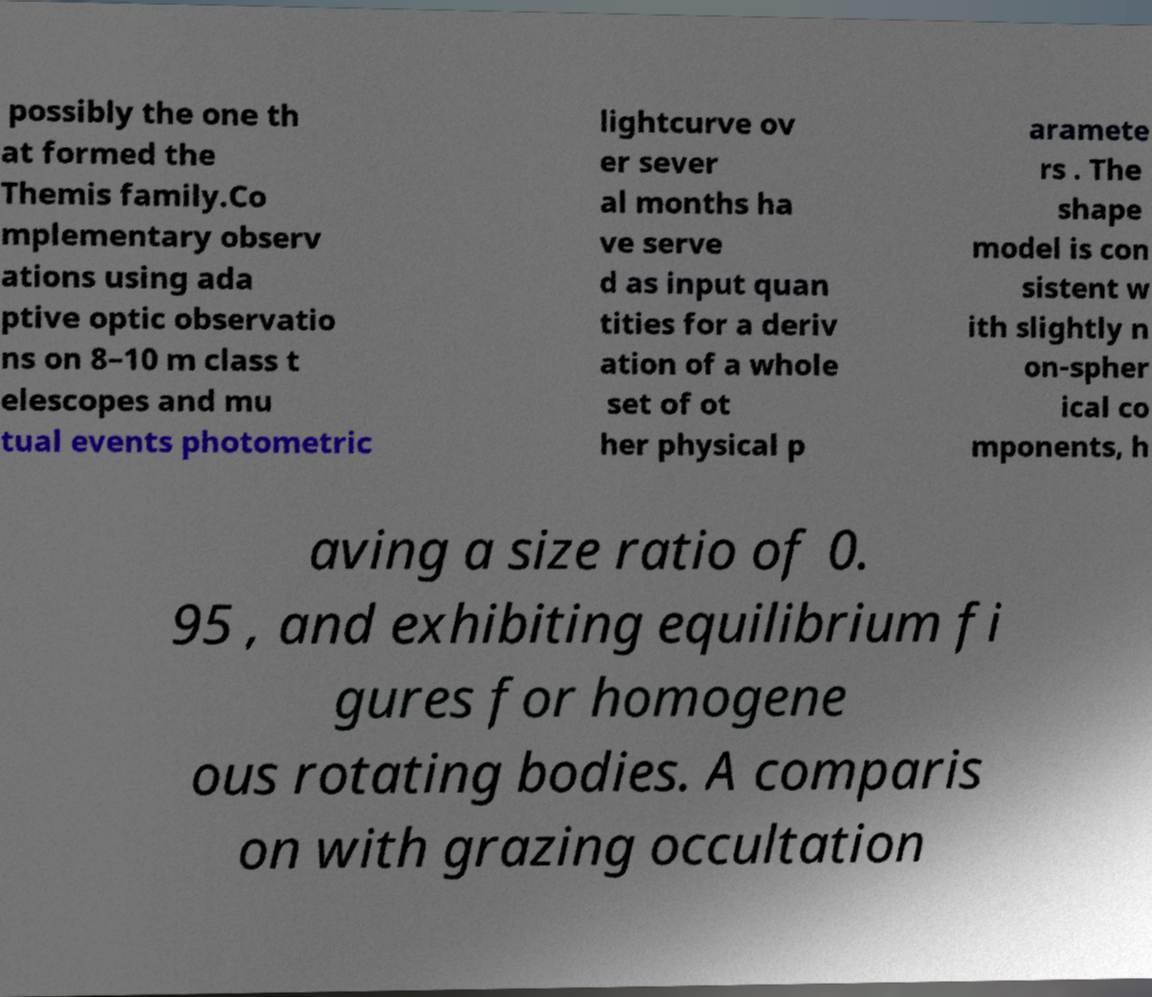Please identify and transcribe the text found in this image. possibly the one th at formed the Themis family.Co mplementary observ ations using ada ptive optic observatio ns on 8–10 m class t elescopes and mu tual events photometric lightcurve ov er sever al months ha ve serve d as input quan tities for a deriv ation of a whole set of ot her physical p aramete rs . The shape model is con sistent w ith slightly n on-spher ical co mponents, h aving a size ratio of 0. 95 , and exhibiting equilibrium fi gures for homogene ous rotating bodies. A comparis on with grazing occultation 